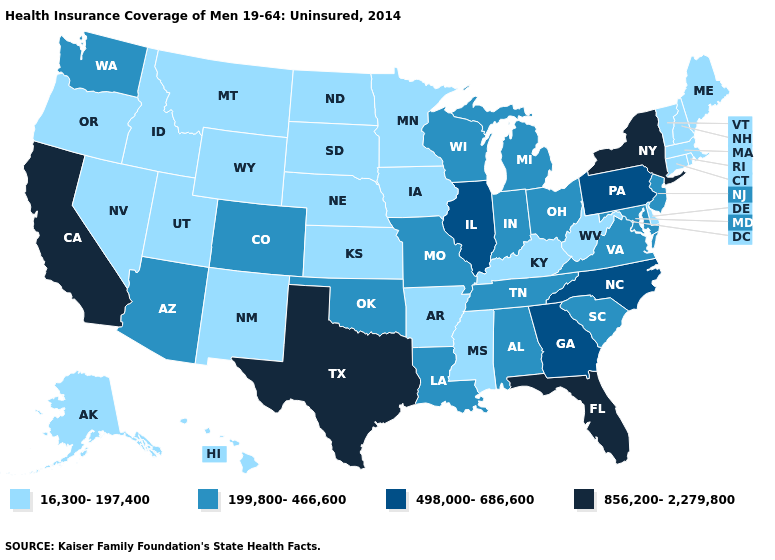Is the legend a continuous bar?
Give a very brief answer. No. Does California have the highest value in the USA?
Write a very short answer. Yes. What is the value of Alaska?
Write a very short answer. 16,300-197,400. What is the lowest value in the USA?
Be succinct. 16,300-197,400. Name the states that have a value in the range 16,300-197,400?
Concise answer only. Alaska, Arkansas, Connecticut, Delaware, Hawaii, Idaho, Iowa, Kansas, Kentucky, Maine, Massachusetts, Minnesota, Mississippi, Montana, Nebraska, Nevada, New Hampshire, New Mexico, North Dakota, Oregon, Rhode Island, South Dakota, Utah, Vermont, West Virginia, Wyoming. Does Minnesota have the same value as Ohio?
Be succinct. No. Does Ohio have the same value as Louisiana?
Concise answer only. Yes. Does Louisiana have the highest value in the South?
Concise answer only. No. Name the states that have a value in the range 856,200-2,279,800?
Concise answer only. California, Florida, New York, Texas. Does the first symbol in the legend represent the smallest category?
Give a very brief answer. Yes. Name the states that have a value in the range 498,000-686,600?
Be succinct. Georgia, Illinois, North Carolina, Pennsylvania. Which states have the lowest value in the West?
Keep it brief. Alaska, Hawaii, Idaho, Montana, Nevada, New Mexico, Oregon, Utah, Wyoming. Does New York have the highest value in the USA?
Concise answer only. Yes. Which states have the lowest value in the USA?
Give a very brief answer. Alaska, Arkansas, Connecticut, Delaware, Hawaii, Idaho, Iowa, Kansas, Kentucky, Maine, Massachusetts, Minnesota, Mississippi, Montana, Nebraska, Nevada, New Hampshire, New Mexico, North Dakota, Oregon, Rhode Island, South Dakota, Utah, Vermont, West Virginia, Wyoming. Does Oregon have the lowest value in the USA?
Write a very short answer. Yes. 